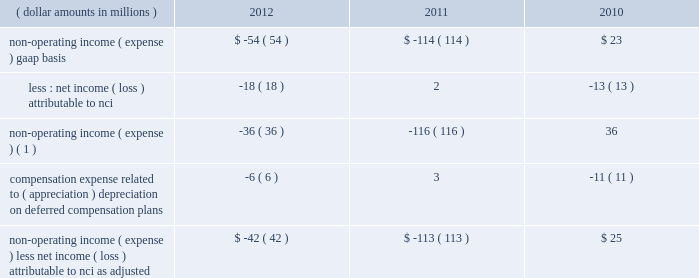The portion of compensation expense associated with certain long-term incentive plans ( 201cltip 201d ) funded or to be funded through share distributions to participants of blackrock stock held by pnc and a merrill lynch & co. , inc .
( 201cmerrill lynch 201d ) cash compensation contribution , has been excluded because it ultimately does not impact blackrock 2019s book value .
The expense related to the merrill lynch cash compensation contribution ceased at the end of third quarter 2011 .
As of first quarter 2012 , all of the merrill lynch contributions had been received .
Compensation expense associated with appreciation ( depreciation ) on investments related to certain blackrock deferred compensation plans has been excluded as returns on investments set aside for these plans , which substantially offset this expense , are reported in non-operating income ( expense ) .
Management believes operating income exclusive of these items is a useful measure in evaluating blackrock 2019s operating performance and helps enhance the comparability of this information for the reporting periods presented .
Operating margin , as adjusted : operating income used for measuring operating margin , as adjusted , is equal to operating income , as adjusted , excluding the impact of closed-end fund launch costs and commissions .
Management believes the exclusion of such costs and commissions is useful because these costs can fluctuate considerably and revenues associated with the expenditure of these costs will not fully impact the company 2019s results until future periods .
Operating margin , as adjusted , allows the company to compare performance from period-to-period by adjusting for items that may not recur , recur infrequently or may have an economic offset in non-operating income ( expense ) .
Examples of such adjustments include bgi transaction and integration costs , u.k .
Lease exit costs , contribution to stifs , restructuring charges , closed-end fund launch costs , commissions paid to certain employees as compensation and fluctuations in compensation expense based on mark-to-market movements in investments held to fund certain compensation plans .
The company also uses operating margin , as adjusted , to monitor corporate performance and efficiency and as a benchmark to compare its performance with other companies .
Management uses both the gaap and non- gaap financial measures in evaluating the financial performance of blackrock .
The non-gaap measure by itself may pose limitations because it does not include all of the company 2019s revenues and expenses .
Revenue used for operating margin , as adjusted , excludes distribution and servicing costs paid to related parties and other third parties .
Management believes the exclusion of such costs is useful because it creates consistency in the treatment for certain contracts for similar services , which due to the terms of the contracts , are accounted for under gaap on a net basis within investment advisory , administration fees and securities lending revenue .
Amortization of deferred sales commissions is excluded from revenue used for operating margin measurement , as adjusted , because such costs , over time , substantially offset distribution fee revenue earned by the company .
For each of these items , blackrock excludes from revenue used for operating margin , as adjusted , the costs related to each of these items as a proxy for such offsetting revenues .
( b ) non-operating income ( expense ) , less net income ( loss ) attributable to non-controlling interests , as adjusted : non-operating income ( expense ) , less net income ( loss ) attributable to nci , as adjusted , is presented below .
The compensation expense offset is recorded in operating income .
This compensation expense has been included in non-operating income ( expense ) , less net income ( loss ) attributable to nci , as adjusted , to offset returns on investments set aside for these plans , which are reported in non-operating income ( expense ) , gaap basis .
( dollar amounts in millions ) 2012 2011 2010 non-operating income ( expense ) , gaap basis .
$ ( 54 ) $ ( 114 ) $ 23 less : net income ( loss ) attributable to nci .
( 18 ) 2 ( 13 ) non-operating income ( expense ) ( 1 ) .
( 36 ) ( 116 ) 36 compensation expense related to ( appreciation ) depreciation on deferred compensation plans .
( 6 ) 3 ( 11 ) non-operating income ( expense ) , less net income ( loss ) attributable to nci , as adjusted .
$ ( 42 ) $ ( 113 ) $ 25 ( 1 ) net of net income ( loss ) attributable to nci .
Management believes non-operating income ( expense ) , less net income ( loss ) attributable to nci , as adjusted , provides comparability of this information among reporting periods and is an effective measure for reviewing blackrock 2019s non-operating contribution to its results .
As compensation expense associated with ( appreciation ) depreciation on investments related to certain deferred compensation plans , which is included in operating income , substantially offsets the gain ( loss ) on the investments set aside for these plans , management .
The portion of compensation expense associated with certain long-term incentive plans ( 201cltip 201d ) funded or to be funded through share distributions to participants of blackrock stock held by pnc and a merrill lynch & co. , inc .
( 201cmerrill lynch 201d ) cash compensation contribution , has been excluded because it ultimately does not impact blackrock 2019s book value .
The expense related to the merrill lynch cash compensation contribution ceased at the end of third quarter 2011 .
As of first quarter 2012 , all of the merrill lynch contributions had been received .
Compensation expense associated with appreciation ( depreciation ) on investments related to certain blackrock deferred compensation plans has been excluded as returns on investments set aside for these plans , which substantially offset this expense , are reported in non-operating income ( expense ) .
Management believes operating income exclusive of these items is a useful measure in evaluating blackrock 2019s operating performance and helps enhance the comparability of this information for the reporting periods presented .
Operating margin , as adjusted : operating income used for measuring operating margin , as adjusted , is equal to operating income , as adjusted , excluding the impact of closed-end fund launch costs and commissions .
Management believes the exclusion of such costs and commissions is useful because these costs can fluctuate considerably and revenues associated with the expenditure of these costs will not fully impact the company 2019s results until future periods .
Operating margin , as adjusted , allows the company to compare performance from period-to-period by adjusting for items that may not recur , recur infrequently or may have an economic offset in non-operating income ( expense ) .
Examples of such adjustments include bgi transaction and integration costs , u.k .
Lease exit costs , contribution to stifs , restructuring charges , closed-end fund launch costs , commissions paid to certain employees as compensation and fluctuations in compensation expense based on mark-to-market movements in investments held to fund certain compensation plans .
The company also uses operating margin , as adjusted , to monitor corporate performance and efficiency and as a benchmark to compare its performance with other companies .
Management uses both the gaap and non- gaap financial measures in evaluating the financial performance of blackrock .
The non-gaap measure by itself may pose limitations because it does not include all of the company 2019s revenues and expenses .
Revenue used for operating margin , as adjusted , excludes distribution and servicing costs paid to related parties and other third parties .
Management believes the exclusion of such costs is useful because it creates consistency in the treatment for certain contracts for similar services , which due to the terms of the contracts , are accounted for under gaap on a net basis within investment advisory , administration fees and securities lending revenue .
Amortization of deferred sales commissions is excluded from revenue used for operating margin measurement , as adjusted , because such costs , over time , substantially offset distribution fee revenue earned by the company .
For each of these items , blackrock excludes from revenue used for operating margin , as adjusted , the costs related to each of these items as a proxy for such offsetting revenues .
( b ) non-operating income ( expense ) , less net income ( loss ) attributable to non-controlling interests , as adjusted : non-operating income ( expense ) , less net income ( loss ) attributable to nci , as adjusted , is presented below .
The compensation expense offset is recorded in operating income .
This compensation expense has been included in non-operating income ( expense ) , less net income ( loss ) attributable to nci , as adjusted , to offset returns on investments set aside for these plans , which are reported in non-operating income ( expense ) , gaap basis .
( dollar amounts in millions ) 2012 2011 2010 non-operating income ( expense ) , gaap basis .
$ ( 54 ) $ ( 114 ) $ 23 less : net income ( loss ) attributable to nci .
( 18 ) 2 ( 13 ) non-operating income ( expense ) ( 1 ) .
( 36 ) ( 116 ) 36 compensation expense related to ( appreciation ) depreciation on deferred compensation plans .
( 6 ) 3 ( 11 ) non-operating income ( expense ) , less net income ( loss ) attributable to nci , as adjusted .
$ ( 42 ) $ ( 113 ) $ 25 ( 1 ) net of net income ( loss ) attributable to nci .
Management believes non-operating income ( expense ) , less net income ( loss ) attributable to nci , as adjusted , provides comparability of this information among reporting periods and is an effective measure for reviewing blackrock 2019s non-operating contribution to its results .
As compensation expense associated with ( appreciation ) depreciation on investments related to certain deferred compensation plans , which is included in operating income , substantially offsets the gain ( loss ) on the investments set aside for these plans , management .
What is the value of the non operating expenses between 2010 and 2012 ? in millions $ .? 
Rationale: way too many lines
Computations: ((54 + 114) - 23)
Answer: 145.0. The portion of compensation expense associated with certain long-term incentive plans ( 201cltip 201d ) funded or to be funded through share distributions to participants of blackrock stock held by pnc and a merrill lynch & co. , inc .
( 201cmerrill lynch 201d ) cash compensation contribution , has been excluded because it ultimately does not impact blackrock 2019s book value .
The expense related to the merrill lynch cash compensation contribution ceased at the end of third quarter 2011 .
As of first quarter 2012 , all of the merrill lynch contributions had been received .
Compensation expense associated with appreciation ( depreciation ) on investments related to certain blackrock deferred compensation plans has been excluded as returns on investments set aside for these plans , which substantially offset this expense , are reported in non-operating income ( expense ) .
Management believes operating income exclusive of these items is a useful measure in evaluating blackrock 2019s operating performance and helps enhance the comparability of this information for the reporting periods presented .
Operating margin , as adjusted : operating income used for measuring operating margin , as adjusted , is equal to operating income , as adjusted , excluding the impact of closed-end fund launch costs and commissions .
Management believes the exclusion of such costs and commissions is useful because these costs can fluctuate considerably and revenues associated with the expenditure of these costs will not fully impact the company 2019s results until future periods .
Operating margin , as adjusted , allows the company to compare performance from period-to-period by adjusting for items that may not recur , recur infrequently or may have an economic offset in non-operating income ( expense ) .
Examples of such adjustments include bgi transaction and integration costs , u.k .
Lease exit costs , contribution to stifs , restructuring charges , closed-end fund launch costs , commissions paid to certain employees as compensation and fluctuations in compensation expense based on mark-to-market movements in investments held to fund certain compensation plans .
The company also uses operating margin , as adjusted , to monitor corporate performance and efficiency and as a benchmark to compare its performance with other companies .
Management uses both the gaap and non- gaap financial measures in evaluating the financial performance of blackrock .
The non-gaap measure by itself may pose limitations because it does not include all of the company 2019s revenues and expenses .
Revenue used for operating margin , as adjusted , excludes distribution and servicing costs paid to related parties and other third parties .
Management believes the exclusion of such costs is useful because it creates consistency in the treatment for certain contracts for similar services , which due to the terms of the contracts , are accounted for under gaap on a net basis within investment advisory , administration fees and securities lending revenue .
Amortization of deferred sales commissions is excluded from revenue used for operating margin measurement , as adjusted , because such costs , over time , substantially offset distribution fee revenue earned by the company .
For each of these items , blackrock excludes from revenue used for operating margin , as adjusted , the costs related to each of these items as a proxy for such offsetting revenues .
( b ) non-operating income ( expense ) , less net income ( loss ) attributable to non-controlling interests , as adjusted : non-operating income ( expense ) , less net income ( loss ) attributable to nci , as adjusted , is presented below .
The compensation expense offset is recorded in operating income .
This compensation expense has been included in non-operating income ( expense ) , less net income ( loss ) attributable to nci , as adjusted , to offset returns on investments set aside for these plans , which are reported in non-operating income ( expense ) , gaap basis .
( dollar amounts in millions ) 2012 2011 2010 non-operating income ( expense ) , gaap basis .
$ ( 54 ) $ ( 114 ) $ 23 less : net income ( loss ) attributable to nci .
( 18 ) 2 ( 13 ) non-operating income ( expense ) ( 1 ) .
( 36 ) ( 116 ) 36 compensation expense related to ( appreciation ) depreciation on deferred compensation plans .
( 6 ) 3 ( 11 ) non-operating income ( expense ) , less net income ( loss ) attributable to nci , as adjusted .
$ ( 42 ) $ ( 113 ) $ 25 ( 1 ) net of net income ( loss ) attributable to nci .
Management believes non-operating income ( expense ) , less net income ( loss ) attributable to nci , as adjusted , provides comparability of this information among reporting periods and is an effective measure for reviewing blackrock 2019s non-operating contribution to its results .
As compensation expense associated with ( appreciation ) depreciation on investments related to certain deferred compensation plans , which is included in operating income , substantially offsets the gain ( loss ) on the investments set aside for these plans , management .
The portion of compensation expense associated with certain long-term incentive plans ( 201cltip 201d ) funded or to be funded through share distributions to participants of blackrock stock held by pnc and a merrill lynch & co. , inc .
( 201cmerrill lynch 201d ) cash compensation contribution , has been excluded because it ultimately does not impact blackrock 2019s book value .
The expense related to the merrill lynch cash compensation contribution ceased at the end of third quarter 2011 .
As of first quarter 2012 , all of the merrill lynch contributions had been received .
Compensation expense associated with appreciation ( depreciation ) on investments related to certain blackrock deferred compensation plans has been excluded as returns on investments set aside for these plans , which substantially offset this expense , are reported in non-operating income ( expense ) .
Management believes operating income exclusive of these items is a useful measure in evaluating blackrock 2019s operating performance and helps enhance the comparability of this information for the reporting periods presented .
Operating margin , as adjusted : operating income used for measuring operating margin , as adjusted , is equal to operating income , as adjusted , excluding the impact of closed-end fund launch costs and commissions .
Management believes the exclusion of such costs and commissions is useful because these costs can fluctuate considerably and revenues associated with the expenditure of these costs will not fully impact the company 2019s results until future periods .
Operating margin , as adjusted , allows the company to compare performance from period-to-period by adjusting for items that may not recur , recur infrequently or may have an economic offset in non-operating income ( expense ) .
Examples of such adjustments include bgi transaction and integration costs , u.k .
Lease exit costs , contribution to stifs , restructuring charges , closed-end fund launch costs , commissions paid to certain employees as compensation and fluctuations in compensation expense based on mark-to-market movements in investments held to fund certain compensation plans .
The company also uses operating margin , as adjusted , to monitor corporate performance and efficiency and as a benchmark to compare its performance with other companies .
Management uses both the gaap and non- gaap financial measures in evaluating the financial performance of blackrock .
The non-gaap measure by itself may pose limitations because it does not include all of the company 2019s revenues and expenses .
Revenue used for operating margin , as adjusted , excludes distribution and servicing costs paid to related parties and other third parties .
Management believes the exclusion of such costs is useful because it creates consistency in the treatment for certain contracts for similar services , which due to the terms of the contracts , are accounted for under gaap on a net basis within investment advisory , administration fees and securities lending revenue .
Amortization of deferred sales commissions is excluded from revenue used for operating margin measurement , as adjusted , because such costs , over time , substantially offset distribution fee revenue earned by the company .
For each of these items , blackrock excludes from revenue used for operating margin , as adjusted , the costs related to each of these items as a proxy for such offsetting revenues .
( b ) non-operating income ( expense ) , less net income ( loss ) attributable to non-controlling interests , as adjusted : non-operating income ( expense ) , less net income ( loss ) attributable to nci , as adjusted , is presented below .
The compensation expense offset is recorded in operating income .
This compensation expense has been included in non-operating income ( expense ) , less net income ( loss ) attributable to nci , as adjusted , to offset returns on investments set aside for these plans , which are reported in non-operating income ( expense ) , gaap basis .
( dollar amounts in millions ) 2012 2011 2010 non-operating income ( expense ) , gaap basis .
$ ( 54 ) $ ( 114 ) $ 23 less : net income ( loss ) attributable to nci .
( 18 ) 2 ( 13 ) non-operating income ( expense ) ( 1 ) .
( 36 ) ( 116 ) 36 compensation expense related to ( appreciation ) depreciation on deferred compensation plans .
( 6 ) 3 ( 11 ) non-operating income ( expense ) , less net income ( loss ) attributable to nci , as adjusted .
$ ( 42 ) $ ( 113 ) $ 25 ( 1 ) net of net income ( loss ) attributable to nci .
Management believes non-operating income ( expense ) , less net income ( loss ) attributable to nci , as adjusted , provides comparability of this information among reporting periods and is an effective measure for reviewing blackrock 2019s non-operating contribution to its results .
As compensation expense associated with ( appreciation ) depreciation on investments related to certain deferred compensation plans , which is included in operating income , substantially offsets the gain ( loss ) on the investments set aside for these plans , management .
What is the net change in non-operating income from 2011 to 2012? 
Computations: (-36 - -116)
Answer: 80.0. 